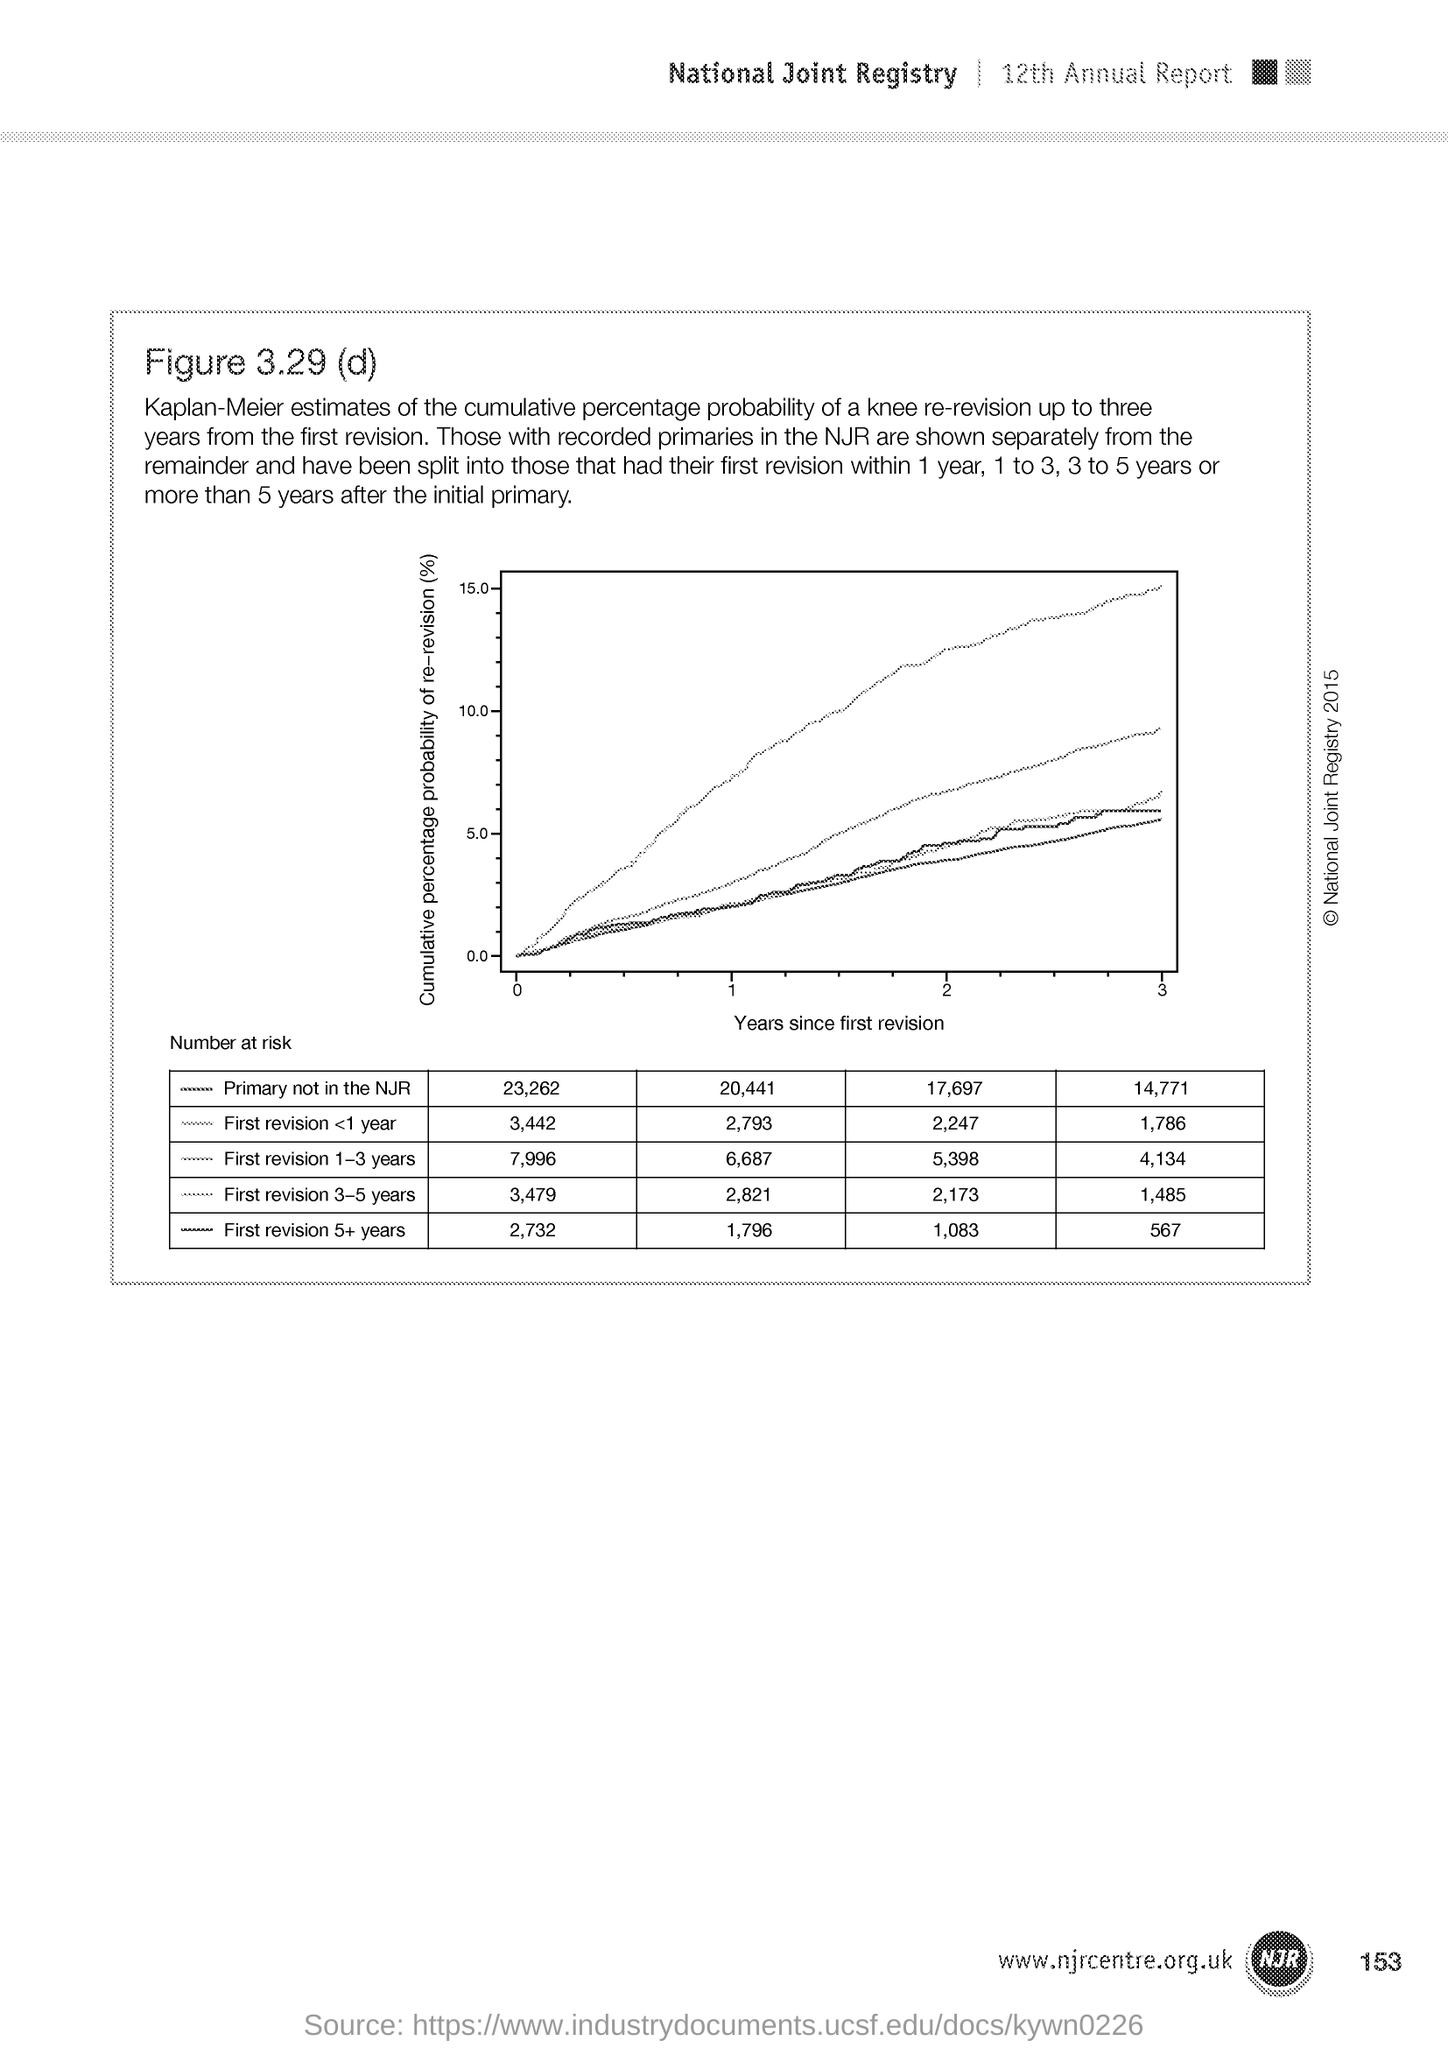What is the number at bottom right side of the page?
Provide a succinct answer. 153. 